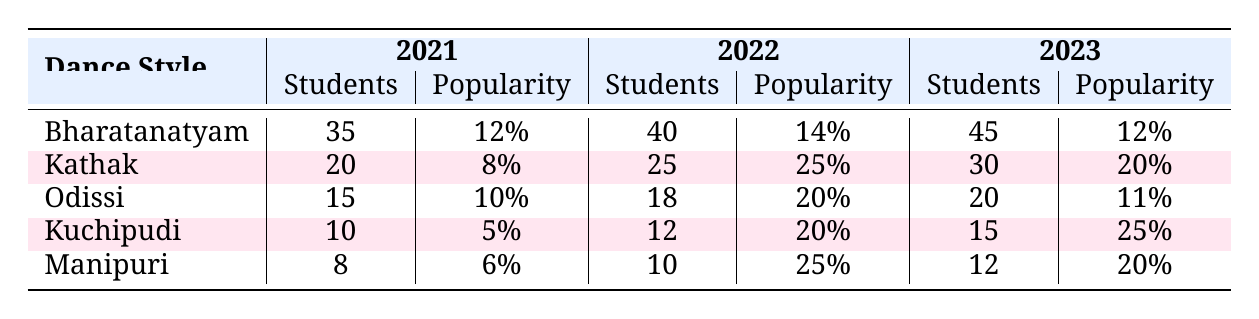What dance style had the highest number of students in 2023? Referring to the 2023 column in the table, Bharatanatyam had 45 students, which is the highest among all styles for that year.
Answer: Bharatanatyam What was the percentage increase in popularity for Kuchipudi from 2022 to 2023? The popularity percentage for Kuchipudi in 2022 was 20%, and in 2023 it increased to 25%. The increase is calculated as (25% - 20%) = 5%.
Answer: 5% Which dance style showed the largest increase in the number of students from 2021 to 2022? Kuchipudi had an increase from 10 students in 2021 to 12 in 2022, which is 2 students. Kathak increased from 20 to 25, which is 5 students. The largest increase is for Kathak.
Answer: Kathak What was the average number of students enrolled in Odissi over the three years? The number of students for Odissi over the three years is 15 (2021) + 18 (2022) + 20 (2023) = 53. Dividing this sum by 3 gives an average of 53/3 ≈ 17.67.
Answer: 17.67 Was the popularity of Manipuri higher in 2023 compared to 2021? The popularity of Manipuri in 2021 was 6% and in 2023 it was 20%. Since 20% is greater than 6%, the statement is true.
Answer: Yes What is the total number of students for all dance styles in 2022? Adding the number of students in 2022: 40 (Bharatanatyam) + 25 (Kathak) + 18 (Odissi) + 12 (Kuchipudi) + 10 (Manipuri) = 115.
Answer: 115 Which dance style consistently had the lowest number of students from 2021 to 2023? By examining the student numbers for each year, Manipuri consistently had the lowest: 8 (2021), 10 (2022), and 12 (2023).
Answer: Manipuri Did Odissi show a higher popularity increase percentage in 2022 than in 2023? Odissi's popularity increase was 20% in 2022 and 11% in 2023. Since 20% is greater than 11%, the statement is true.
Answer: Yes What is the difference in the number of students between Bharatanatyam and Kathak in 2021? Bharatanatyam had 35 students and Kathak had 20 students in 2021. The difference is 35 - 20 = 15 students.
Answer: 15 If we consider the average popularity across the three years for Kuchipudi, what is that value? Calculating the average popularity: (5% + 20% + 25%) / 3 = 50% / 3 ≈ 16.67%.
Answer: 16.67 